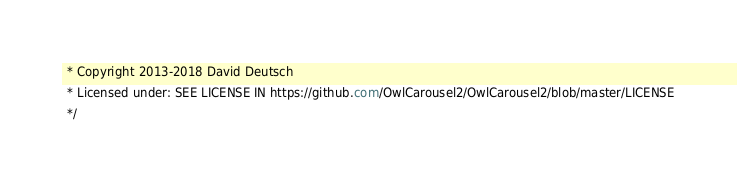Convert code to text. <code><loc_0><loc_0><loc_500><loc_500><_CSS_> * Copyright 2013-2018 David Deutsch
 * Licensed under: SEE LICENSE IN https://github.com/OwlCarousel2/OwlCarousel2/blob/master/LICENSE
 */</code> 